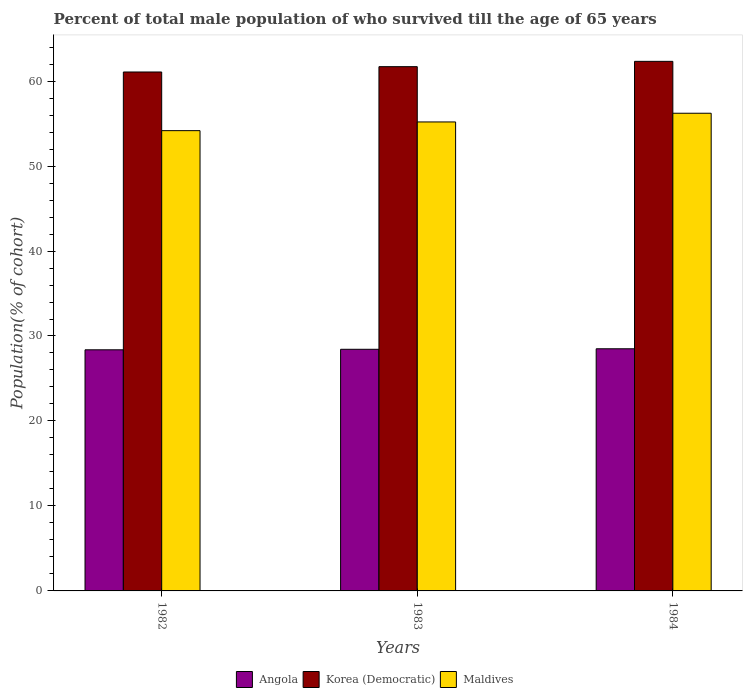Are the number of bars on each tick of the X-axis equal?
Your response must be concise. Yes. How many bars are there on the 2nd tick from the left?
Your response must be concise. 3. How many bars are there on the 1st tick from the right?
Keep it short and to the point. 3. What is the percentage of total male population who survived till the age of 65 years in Korea (Democratic) in 1984?
Your answer should be compact. 62.32. Across all years, what is the maximum percentage of total male population who survived till the age of 65 years in Angola?
Give a very brief answer. 28.5. Across all years, what is the minimum percentage of total male population who survived till the age of 65 years in Maldives?
Keep it short and to the point. 54.17. In which year was the percentage of total male population who survived till the age of 65 years in Korea (Democratic) maximum?
Your answer should be very brief. 1984. What is the total percentage of total male population who survived till the age of 65 years in Maldives in the graph?
Offer a terse response. 165.57. What is the difference between the percentage of total male population who survived till the age of 65 years in Maldives in 1982 and that in 1983?
Your answer should be very brief. -1.02. What is the difference between the percentage of total male population who survived till the age of 65 years in Maldives in 1983 and the percentage of total male population who survived till the age of 65 years in Korea (Democratic) in 1984?
Your answer should be very brief. -7.13. What is the average percentage of total male population who survived till the age of 65 years in Angola per year?
Give a very brief answer. 28.44. In the year 1983, what is the difference between the percentage of total male population who survived till the age of 65 years in Angola and percentage of total male population who survived till the age of 65 years in Maldives?
Keep it short and to the point. -26.75. What is the ratio of the percentage of total male population who survived till the age of 65 years in Korea (Democratic) in 1982 to that in 1983?
Keep it short and to the point. 0.99. What is the difference between the highest and the second highest percentage of total male population who survived till the age of 65 years in Korea (Democratic)?
Offer a very short reply. 0.63. What is the difference between the highest and the lowest percentage of total male population who survived till the age of 65 years in Korea (Democratic)?
Your answer should be compact. 1.25. In how many years, is the percentage of total male population who survived till the age of 65 years in Angola greater than the average percentage of total male population who survived till the age of 65 years in Angola taken over all years?
Provide a short and direct response. 1. Is the sum of the percentage of total male population who survived till the age of 65 years in Maldives in 1983 and 1984 greater than the maximum percentage of total male population who survived till the age of 65 years in Angola across all years?
Give a very brief answer. Yes. What does the 3rd bar from the left in 1984 represents?
Offer a very short reply. Maldives. What does the 3rd bar from the right in 1983 represents?
Make the answer very short. Angola. Is it the case that in every year, the sum of the percentage of total male population who survived till the age of 65 years in Maldives and percentage of total male population who survived till the age of 65 years in Korea (Democratic) is greater than the percentage of total male population who survived till the age of 65 years in Angola?
Provide a succinct answer. Yes. Are all the bars in the graph horizontal?
Your answer should be very brief. No. How many years are there in the graph?
Provide a short and direct response. 3. Does the graph contain any zero values?
Keep it short and to the point. No. Does the graph contain grids?
Your answer should be very brief. No. How are the legend labels stacked?
Your answer should be compact. Horizontal. What is the title of the graph?
Provide a short and direct response. Percent of total male population of who survived till the age of 65 years. What is the label or title of the Y-axis?
Offer a terse response. Population(% of cohort). What is the Population(% of cohort) of Angola in 1982?
Provide a short and direct response. 28.37. What is the Population(% of cohort) in Korea (Democratic) in 1982?
Give a very brief answer. 61.07. What is the Population(% of cohort) of Maldives in 1982?
Provide a succinct answer. 54.17. What is the Population(% of cohort) in Angola in 1983?
Your response must be concise. 28.44. What is the Population(% of cohort) in Korea (Democratic) in 1983?
Offer a very short reply. 61.69. What is the Population(% of cohort) of Maldives in 1983?
Your answer should be very brief. 55.19. What is the Population(% of cohort) of Angola in 1984?
Your answer should be very brief. 28.5. What is the Population(% of cohort) in Korea (Democratic) in 1984?
Provide a succinct answer. 62.32. What is the Population(% of cohort) in Maldives in 1984?
Your answer should be very brief. 56.21. Across all years, what is the maximum Population(% of cohort) of Angola?
Make the answer very short. 28.5. Across all years, what is the maximum Population(% of cohort) in Korea (Democratic)?
Provide a succinct answer. 62.32. Across all years, what is the maximum Population(% of cohort) in Maldives?
Keep it short and to the point. 56.21. Across all years, what is the minimum Population(% of cohort) of Angola?
Provide a short and direct response. 28.37. Across all years, what is the minimum Population(% of cohort) in Korea (Democratic)?
Offer a terse response. 61.07. Across all years, what is the minimum Population(% of cohort) of Maldives?
Provide a succinct answer. 54.17. What is the total Population(% of cohort) in Angola in the graph?
Give a very brief answer. 85.31. What is the total Population(% of cohort) in Korea (Democratic) in the graph?
Give a very brief answer. 185.08. What is the total Population(% of cohort) of Maldives in the graph?
Provide a short and direct response. 165.57. What is the difference between the Population(% of cohort) in Angola in 1982 and that in 1983?
Keep it short and to the point. -0.06. What is the difference between the Population(% of cohort) in Korea (Democratic) in 1982 and that in 1983?
Your answer should be very brief. -0.63. What is the difference between the Population(% of cohort) in Maldives in 1982 and that in 1983?
Keep it short and to the point. -1.02. What is the difference between the Population(% of cohort) of Angola in 1982 and that in 1984?
Make the answer very short. -0.12. What is the difference between the Population(% of cohort) in Korea (Democratic) in 1982 and that in 1984?
Your answer should be compact. -1.25. What is the difference between the Population(% of cohort) in Maldives in 1982 and that in 1984?
Your answer should be compact. -2.05. What is the difference between the Population(% of cohort) in Angola in 1983 and that in 1984?
Your answer should be very brief. -0.06. What is the difference between the Population(% of cohort) of Korea (Democratic) in 1983 and that in 1984?
Offer a terse response. -0.63. What is the difference between the Population(% of cohort) of Maldives in 1983 and that in 1984?
Provide a short and direct response. -1.02. What is the difference between the Population(% of cohort) in Angola in 1982 and the Population(% of cohort) in Korea (Democratic) in 1983?
Offer a terse response. -33.32. What is the difference between the Population(% of cohort) in Angola in 1982 and the Population(% of cohort) in Maldives in 1983?
Provide a succinct answer. -26.82. What is the difference between the Population(% of cohort) of Korea (Democratic) in 1982 and the Population(% of cohort) of Maldives in 1983?
Offer a very short reply. 5.88. What is the difference between the Population(% of cohort) in Angola in 1982 and the Population(% of cohort) in Korea (Democratic) in 1984?
Your answer should be very brief. -33.95. What is the difference between the Population(% of cohort) in Angola in 1982 and the Population(% of cohort) in Maldives in 1984?
Make the answer very short. -27.84. What is the difference between the Population(% of cohort) of Korea (Democratic) in 1982 and the Population(% of cohort) of Maldives in 1984?
Give a very brief answer. 4.85. What is the difference between the Population(% of cohort) in Angola in 1983 and the Population(% of cohort) in Korea (Democratic) in 1984?
Your response must be concise. -33.88. What is the difference between the Population(% of cohort) in Angola in 1983 and the Population(% of cohort) in Maldives in 1984?
Give a very brief answer. -27.78. What is the difference between the Population(% of cohort) of Korea (Democratic) in 1983 and the Population(% of cohort) of Maldives in 1984?
Your response must be concise. 5.48. What is the average Population(% of cohort) in Angola per year?
Your answer should be compact. 28.44. What is the average Population(% of cohort) in Korea (Democratic) per year?
Offer a very short reply. 61.69. What is the average Population(% of cohort) of Maldives per year?
Your answer should be compact. 55.19. In the year 1982, what is the difference between the Population(% of cohort) in Angola and Population(% of cohort) in Korea (Democratic)?
Offer a very short reply. -32.69. In the year 1982, what is the difference between the Population(% of cohort) of Angola and Population(% of cohort) of Maldives?
Offer a very short reply. -25.79. In the year 1982, what is the difference between the Population(% of cohort) of Korea (Democratic) and Population(% of cohort) of Maldives?
Give a very brief answer. 6.9. In the year 1983, what is the difference between the Population(% of cohort) in Angola and Population(% of cohort) in Korea (Democratic)?
Offer a terse response. -33.26. In the year 1983, what is the difference between the Population(% of cohort) in Angola and Population(% of cohort) in Maldives?
Offer a terse response. -26.75. In the year 1983, what is the difference between the Population(% of cohort) in Korea (Democratic) and Population(% of cohort) in Maldives?
Your answer should be very brief. 6.5. In the year 1984, what is the difference between the Population(% of cohort) in Angola and Population(% of cohort) in Korea (Democratic)?
Keep it short and to the point. -33.82. In the year 1984, what is the difference between the Population(% of cohort) of Angola and Population(% of cohort) of Maldives?
Your answer should be compact. -27.72. In the year 1984, what is the difference between the Population(% of cohort) of Korea (Democratic) and Population(% of cohort) of Maldives?
Offer a very short reply. 6.11. What is the ratio of the Population(% of cohort) of Maldives in 1982 to that in 1983?
Keep it short and to the point. 0.98. What is the ratio of the Population(% of cohort) in Korea (Democratic) in 1982 to that in 1984?
Offer a terse response. 0.98. What is the ratio of the Population(% of cohort) in Maldives in 1982 to that in 1984?
Ensure brevity in your answer.  0.96. What is the ratio of the Population(% of cohort) in Korea (Democratic) in 1983 to that in 1984?
Provide a short and direct response. 0.99. What is the ratio of the Population(% of cohort) of Maldives in 1983 to that in 1984?
Your answer should be compact. 0.98. What is the difference between the highest and the second highest Population(% of cohort) in Angola?
Keep it short and to the point. 0.06. What is the difference between the highest and the second highest Population(% of cohort) of Korea (Democratic)?
Make the answer very short. 0.63. What is the difference between the highest and the second highest Population(% of cohort) in Maldives?
Make the answer very short. 1.02. What is the difference between the highest and the lowest Population(% of cohort) of Angola?
Give a very brief answer. 0.12. What is the difference between the highest and the lowest Population(% of cohort) of Korea (Democratic)?
Your answer should be very brief. 1.25. What is the difference between the highest and the lowest Population(% of cohort) in Maldives?
Give a very brief answer. 2.05. 